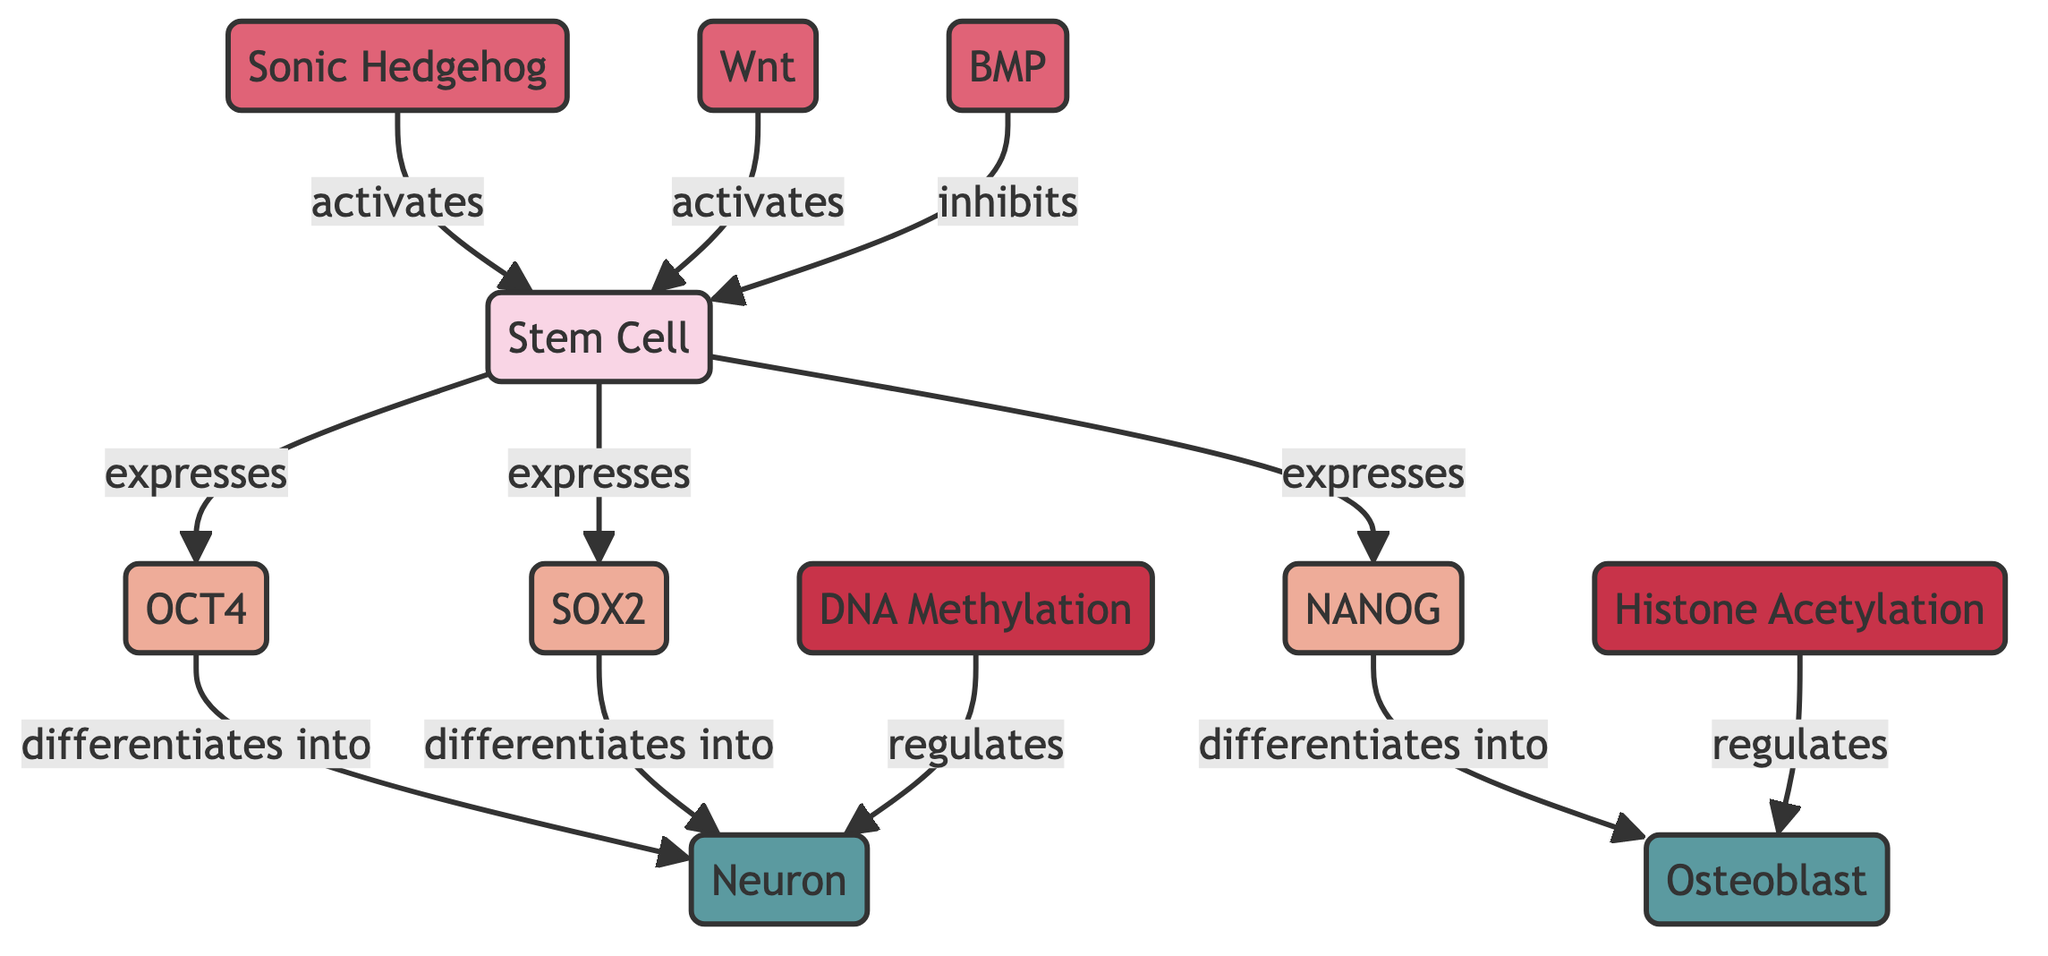What are the main transcription factors expressed by stem cells? The diagram shows three arrows directed from the "Stem Cell" node to the transcription factors: "OCT4," "SOX2," and "NANOG," indicating that these are the transcription factors expressed by stem cells.
Answer: OCT4, SOX2, NANOG How many specialized cell types are depicted in the diagram? The diagram depicts two specialized cell types: "Neuron" and "Osteoblast," as represented by the nodes at the end of the differentiation pathways.
Answer: 2 Which signaling molecule inhibits stem cell activation? The arrow from "Bone Morphogenetic Protein" (BMP) to "Stem Cell" indicates that BMP inhibits stem cell activation, as labeled in the diagram.
Answer: Bone Morphogenetic Protein What is the relationship between OCT4 and specialized neurons? The diagram shows arrows from "OCT4" to "Neuron," indicating that OCT4 differentiates into specialized neurons, providing the relationship that OCT4 is a transcription factor involved in this process.
Answer: differentiates into Which epigenetic mechanism regulates the development of specialized osteoblasts? The connection from "Histone Acetylation" to "Osteoblast" in the diagram specifies that histone acetylation is the epigenetic mechanism regulating the development of specialized osteoblasts.
Answer: Histone Acetylation How does Sonic Hedgehog affect stem cells? An arrow labeled "activates" points from "Sonic Hedgehog" to "Stem Cell," confirming that Sonic Hedgehog activates stem cell activity in the differentiation process.
Answer: activates Which transcription factors contribute to neuronal differentiation? The paths from "OCT4" and "SOX2" to "Neuron" illustrate that both transcription factors play a crucial role in the differentiation into neurons, providing their contributions.
Answer: OCT4, SOX2 What is the overall flow direction of signaling molecules in relation to stem cells? The flow direction can be determined by examining the arrows: both "Sonic Hedgehog" and "Wnt" activate stem cells while "Bone Morphogenetic Protein" inhibits them, illustrating that signaling molecules influence stem cell activity positively or negatively.
Answer: One activates, one inhibits How many different types of nodes are identified in the diagram? The diagram contains five types of nodes: Cell Type, Transcription Factor, Signaling Molecule, Epigenetic Mechanism, and Specialized Cell Type. By counting the categorized types, we see that there are five distinct categories.
Answer: 5 